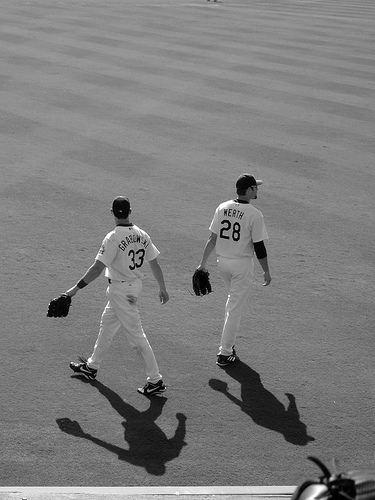What sport are these players likely participating in? Based on their attire, specifically their jerseys and gloves, these players are likely participating in a baseball game. 